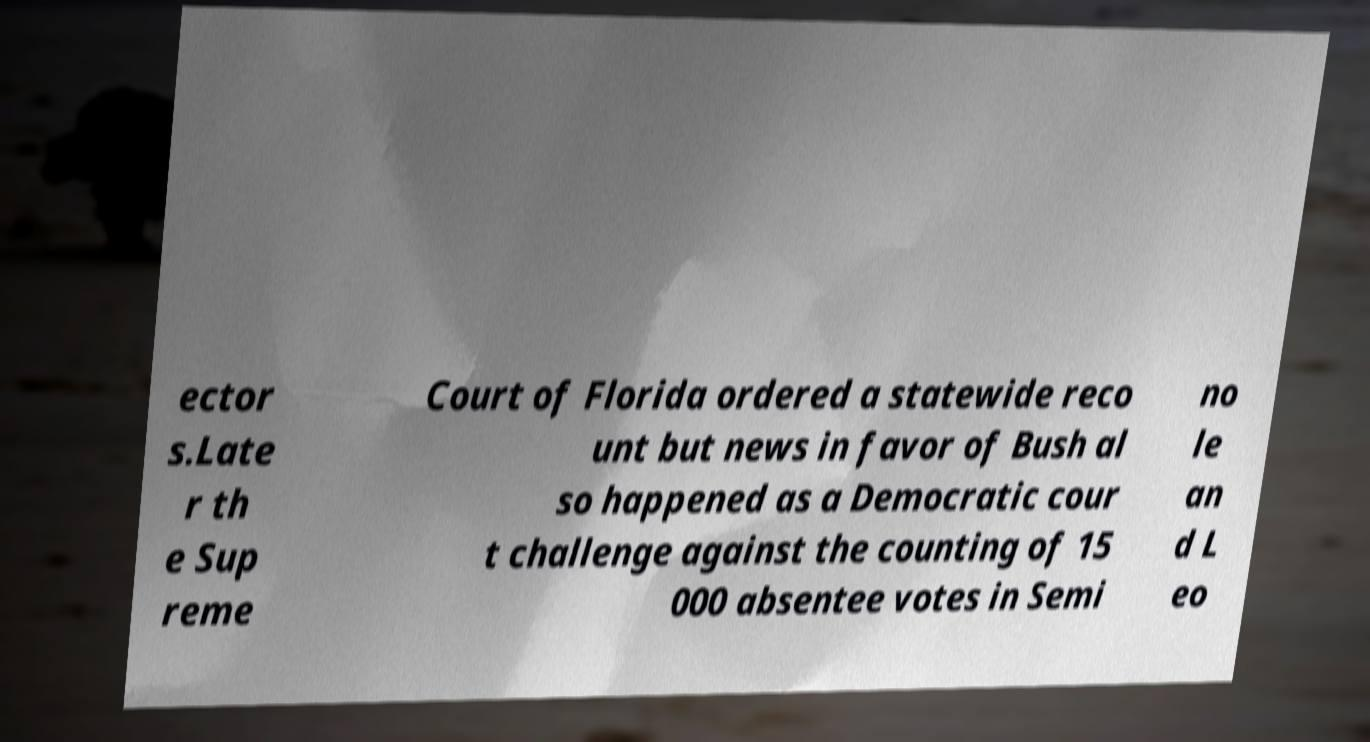Could you extract and type out the text from this image? ector s.Late r th e Sup reme Court of Florida ordered a statewide reco unt but news in favor of Bush al so happened as a Democratic cour t challenge against the counting of 15 000 absentee votes in Semi no le an d L eo 